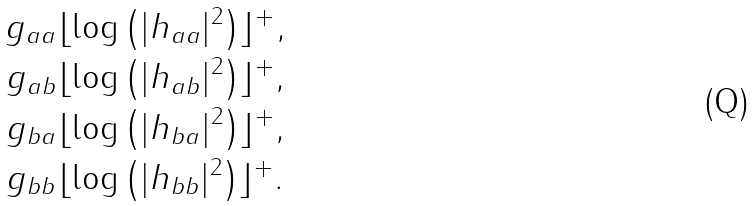<formula> <loc_0><loc_0><loc_500><loc_500>g _ { a a } & \lfloor \log \left ( | h _ { a a } | ^ { 2 } \right ) \rfloor ^ { + } , \\ g _ { a b } & \lfloor \log \left ( | h _ { a b } | ^ { 2 } \right ) \rfloor ^ { + } , \\ g _ { b a } & \lfloor \log \left ( | h _ { b a } | ^ { 2 } \right ) \rfloor ^ { + } , \\ g _ { b b } & \lfloor \log \left ( | h _ { b b } | ^ { 2 } \right ) \rfloor ^ { + } .</formula> 